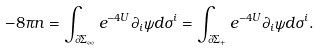Convert formula to latex. <formula><loc_0><loc_0><loc_500><loc_500>- 8 \pi n = \int _ { \partial \Sigma _ { \infty } } e ^ { - 4 U } \partial _ { i } \psi d \sigma ^ { i } = \int _ { \partial \Sigma _ { + } } e ^ { - 4 U } \partial _ { i } \psi d \sigma ^ { i } .</formula> 